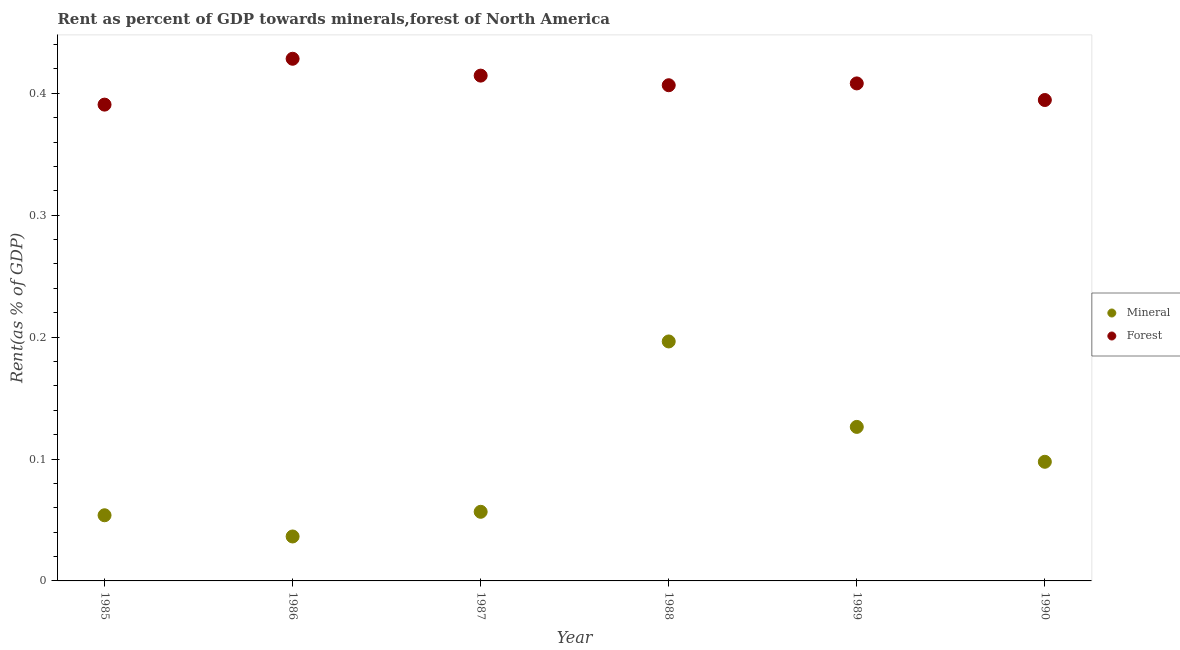How many different coloured dotlines are there?
Provide a succinct answer. 2. Is the number of dotlines equal to the number of legend labels?
Give a very brief answer. Yes. What is the mineral rent in 1985?
Offer a very short reply. 0.05. Across all years, what is the maximum forest rent?
Offer a terse response. 0.43. Across all years, what is the minimum forest rent?
Make the answer very short. 0.39. In which year was the mineral rent maximum?
Offer a very short reply. 1988. In which year was the mineral rent minimum?
Ensure brevity in your answer.  1986. What is the total forest rent in the graph?
Ensure brevity in your answer.  2.44. What is the difference between the mineral rent in 1988 and that in 1989?
Your answer should be very brief. 0.07. What is the difference between the mineral rent in 1990 and the forest rent in 1986?
Provide a short and direct response. -0.33. What is the average forest rent per year?
Give a very brief answer. 0.41. In the year 1990, what is the difference between the forest rent and mineral rent?
Keep it short and to the point. 0.3. What is the ratio of the forest rent in 1986 to that in 1990?
Give a very brief answer. 1.09. Is the mineral rent in 1986 less than that in 1989?
Your answer should be compact. Yes. What is the difference between the highest and the second highest mineral rent?
Your answer should be compact. 0.07. What is the difference between the highest and the lowest forest rent?
Offer a terse response. 0.04. Is the sum of the mineral rent in 1985 and 1987 greater than the maximum forest rent across all years?
Your answer should be compact. No. Is the mineral rent strictly greater than the forest rent over the years?
Your answer should be very brief. No. Is the forest rent strictly less than the mineral rent over the years?
Offer a terse response. No. What is the difference between two consecutive major ticks on the Y-axis?
Give a very brief answer. 0.1. Does the graph contain any zero values?
Ensure brevity in your answer.  No. Where does the legend appear in the graph?
Provide a succinct answer. Center right. How many legend labels are there?
Make the answer very short. 2. What is the title of the graph?
Offer a very short reply. Rent as percent of GDP towards minerals,forest of North America. Does "Urban agglomerations" appear as one of the legend labels in the graph?
Your answer should be compact. No. What is the label or title of the Y-axis?
Provide a succinct answer. Rent(as % of GDP). What is the Rent(as % of GDP) of Mineral in 1985?
Your answer should be compact. 0.05. What is the Rent(as % of GDP) of Forest in 1985?
Provide a succinct answer. 0.39. What is the Rent(as % of GDP) of Mineral in 1986?
Offer a very short reply. 0.04. What is the Rent(as % of GDP) in Forest in 1986?
Your answer should be very brief. 0.43. What is the Rent(as % of GDP) in Mineral in 1987?
Give a very brief answer. 0.06. What is the Rent(as % of GDP) of Forest in 1987?
Ensure brevity in your answer.  0.41. What is the Rent(as % of GDP) of Mineral in 1988?
Your answer should be compact. 0.2. What is the Rent(as % of GDP) in Forest in 1988?
Ensure brevity in your answer.  0.41. What is the Rent(as % of GDP) of Mineral in 1989?
Ensure brevity in your answer.  0.13. What is the Rent(as % of GDP) in Forest in 1989?
Give a very brief answer. 0.41. What is the Rent(as % of GDP) of Mineral in 1990?
Make the answer very short. 0.1. What is the Rent(as % of GDP) in Forest in 1990?
Provide a succinct answer. 0.39. Across all years, what is the maximum Rent(as % of GDP) of Mineral?
Keep it short and to the point. 0.2. Across all years, what is the maximum Rent(as % of GDP) in Forest?
Ensure brevity in your answer.  0.43. Across all years, what is the minimum Rent(as % of GDP) in Mineral?
Provide a short and direct response. 0.04. Across all years, what is the minimum Rent(as % of GDP) of Forest?
Offer a very short reply. 0.39. What is the total Rent(as % of GDP) in Mineral in the graph?
Make the answer very short. 0.57. What is the total Rent(as % of GDP) in Forest in the graph?
Provide a short and direct response. 2.44. What is the difference between the Rent(as % of GDP) in Mineral in 1985 and that in 1986?
Make the answer very short. 0.02. What is the difference between the Rent(as % of GDP) of Forest in 1985 and that in 1986?
Your answer should be compact. -0.04. What is the difference between the Rent(as % of GDP) of Mineral in 1985 and that in 1987?
Offer a very short reply. -0. What is the difference between the Rent(as % of GDP) in Forest in 1985 and that in 1987?
Provide a short and direct response. -0.02. What is the difference between the Rent(as % of GDP) of Mineral in 1985 and that in 1988?
Your answer should be very brief. -0.14. What is the difference between the Rent(as % of GDP) in Forest in 1985 and that in 1988?
Provide a succinct answer. -0.02. What is the difference between the Rent(as % of GDP) in Mineral in 1985 and that in 1989?
Your response must be concise. -0.07. What is the difference between the Rent(as % of GDP) in Forest in 1985 and that in 1989?
Your response must be concise. -0.02. What is the difference between the Rent(as % of GDP) in Mineral in 1985 and that in 1990?
Ensure brevity in your answer.  -0.04. What is the difference between the Rent(as % of GDP) of Forest in 1985 and that in 1990?
Your answer should be compact. -0. What is the difference between the Rent(as % of GDP) of Mineral in 1986 and that in 1987?
Your response must be concise. -0.02. What is the difference between the Rent(as % of GDP) of Forest in 1986 and that in 1987?
Make the answer very short. 0.01. What is the difference between the Rent(as % of GDP) in Mineral in 1986 and that in 1988?
Offer a very short reply. -0.16. What is the difference between the Rent(as % of GDP) in Forest in 1986 and that in 1988?
Your response must be concise. 0.02. What is the difference between the Rent(as % of GDP) of Mineral in 1986 and that in 1989?
Your response must be concise. -0.09. What is the difference between the Rent(as % of GDP) in Forest in 1986 and that in 1989?
Your response must be concise. 0.02. What is the difference between the Rent(as % of GDP) of Mineral in 1986 and that in 1990?
Provide a short and direct response. -0.06. What is the difference between the Rent(as % of GDP) of Forest in 1986 and that in 1990?
Offer a terse response. 0.03. What is the difference between the Rent(as % of GDP) in Mineral in 1987 and that in 1988?
Your answer should be very brief. -0.14. What is the difference between the Rent(as % of GDP) of Forest in 1987 and that in 1988?
Offer a terse response. 0.01. What is the difference between the Rent(as % of GDP) of Mineral in 1987 and that in 1989?
Provide a short and direct response. -0.07. What is the difference between the Rent(as % of GDP) in Forest in 1987 and that in 1989?
Your response must be concise. 0.01. What is the difference between the Rent(as % of GDP) in Mineral in 1987 and that in 1990?
Your response must be concise. -0.04. What is the difference between the Rent(as % of GDP) in Mineral in 1988 and that in 1989?
Provide a succinct answer. 0.07. What is the difference between the Rent(as % of GDP) in Forest in 1988 and that in 1989?
Keep it short and to the point. -0. What is the difference between the Rent(as % of GDP) of Mineral in 1988 and that in 1990?
Your answer should be compact. 0.1. What is the difference between the Rent(as % of GDP) of Forest in 1988 and that in 1990?
Your answer should be compact. 0.01. What is the difference between the Rent(as % of GDP) of Mineral in 1989 and that in 1990?
Your answer should be very brief. 0.03. What is the difference between the Rent(as % of GDP) of Forest in 1989 and that in 1990?
Offer a very short reply. 0.01. What is the difference between the Rent(as % of GDP) of Mineral in 1985 and the Rent(as % of GDP) of Forest in 1986?
Your answer should be very brief. -0.37. What is the difference between the Rent(as % of GDP) in Mineral in 1985 and the Rent(as % of GDP) in Forest in 1987?
Your answer should be compact. -0.36. What is the difference between the Rent(as % of GDP) in Mineral in 1985 and the Rent(as % of GDP) in Forest in 1988?
Offer a terse response. -0.35. What is the difference between the Rent(as % of GDP) of Mineral in 1985 and the Rent(as % of GDP) of Forest in 1989?
Provide a succinct answer. -0.35. What is the difference between the Rent(as % of GDP) of Mineral in 1985 and the Rent(as % of GDP) of Forest in 1990?
Your response must be concise. -0.34. What is the difference between the Rent(as % of GDP) in Mineral in 1986 and the Rent(as % of GDP) in Forest in 1987?
Offer a very short reply. -0.38. What is the difference between the Rent(as % of GDP) of Mineral in 1986 and the Rent(as % of GDP) of Forest in 1988?
Offer a terse response. -0.37. What is the difference between the Rent(as % of GDP) of Mineral in 1986 and the Rent(as % of GDP) of Forest in 1989?
Make the answer very short. -0.37. What is the difference between the Rent(as % of GDP) in Mineral in 1986 and the Rent(as % of GDP) in Forest in 1990?
Your answer should be compact. -0.36. What is the difference between the Rent(as % of GDP) in Mineral in 1987 and the Rent(as % of GDP) in Forest in 1988?
Offer a very short reply. -0.35. What is the difference between the Rent(as % of GDP) in Mineral in 1987 and the Rent(as % of GDP) in Forest in 1989?
Your answer should be compact. -0.35. What is the difference between the Rent(as % of GDP) of Mineral in 1987 and the Rent(as % of GDP) of Forest in 1990?
Keep it short and to the point. -0.34. What is the difference between the Rent(as % of GDP) in Mineral in 1988 and the Rent(as % of GDP) in Forest in 1989?
Provide a short and direct response. -0.21. What is the difference between the Rent(as % of GDP) of Mineral in 1988 and the Rent(as % of GDP) of Forest in 1990?
Your answer should be compact. -0.2. What is the difference between the Rent(as % of GDP) of Mineral in 1989 and the Rent(as % of GDP) of Forest in 1990?
Offer a very short reply. -0.27. What is the average Rent(as % of GDP) in Mineral per year?
Provide a short and direct response. 0.09. What is the average Rent(as % of GDP) of Forest per year?
Provide a short and direct response. 0.41. In the year 1985, what is the difference between the Rent(as % of GDP) of Mineral and Rent(as % of GDP) of Forest?
Your response must be concise. -0.34. In the year 1986, what is the difference between the Rent(as % of GDP) of Mineral and Rent(as % of GDP) of Forest?
Your response must be concise. -0.39. In the year 1987, what is the difference between the Rent(as % of GDP) in Mineral and Rent(as % of GDP) in Forest?
Offer a terse response. -0.36. In the year 1988, what is the difference between the Rent(as % of GDP) in Mineral and Rent(as % of GDP) in Forest?
Your answer should be compact. -0.21. In the year 1989, what is the difference between the Rent(as % of GDP) in Mineral and Rent(as % of GDP) in Forest?
Make the answer very short. -0.28. In the year 1990, what is the difference between the Rent(as % of GDP) of Mineral and Rent(as % of GDP) of Forest?
Your answer should be compact. -0.3. What is the ratio of the Rent(as % of GDP) of Mineral in 1985 to that in 1986?
Offer a very short reply. 1.48. What is the ratio of the Rent(as % of GDP) of Forest in 1985 to that in 1986?
Your answer should be compact. 0.91. What is the ratio of the Rent(as % of GDP) in Mineral in 1985 to that in 1987?
Your answer should be compact. 0.95. What is the ratio of the Rent(as % of GDP) in Forest in 1985 to that in 1987?
Offer a terse response. 0.94. What is the ratio of the Rent(as % of GDP) in Mineral in 1985 to that in 1988?
Your answer should be compact. 0.27. What is the ratio of the Rent(as % of GDP) of Forest in 1985 to that in 1988?
Your answer should be compact. 0.96. What is the ratio of the Rent(as % of GDP) of Mineral in 1985 to that in 1989?
Ensure brevity in your answer.  0.43. What is the ratio of the Rent(as % of GDP) in Forest in 1985 to that in 1989?
Keep it short and to the point. 0.96. What is the ratio of the Rent(as % of GDP) of Mineral in 1985 to that in 1990?
Make the answer very short. 0.55. What is the ratio of the Rent(as % of GDP) of Mineral in 1986 to that in 1987?
Your answer should be very brief. 0.64. What is the ratio of the Rent(as % of GDP) of Forest in 1986 to that in 1987?
Provide a short and direct response. 1.03. What is the ratio of the Rent(as % of GDP) in Mineral in 1986 to that in 1988?
Provide a succinct answer. 0.19. What is the ratio of the Rent(as % of GDP) of Forest in 1986 to that in 1988?
Give a very brief answer. 1.05. What is the ratio of the Rent(as % of GDP) in Mineral in 1986 to that in 1989?
Provide a succinct answer. 0.29. What is the ratio of the Rent(as % of GDP) in Forest in 1986 to that in 1989?
Make the answer very short. 1.05. What is the ratio of the Rent(as % of GDP) of Mineral in 1986 to that in 1990?
Keep it short and to the point. 0.37. What is the ratio of the Rent(as % of GDP) in Forest in 1986 to that in 1990?
Give a very brief answer. 1.09. What is the ratio of the Rent(as % of GDP) of Mineral in 1987 to that in 1988?
Keep it short and to the point. 0.29. What is the ratio of the Rent(as % of GDP) of Forest in 1987 to that in 1988?
Your response must be concise. 1.02. What is the ratio of the Rent(as % of GDP) in Mineral in 1987 to that in 1989?
Offer a terse response. 0.45. What is the ratio of the Rent(as % of GDP) in Forest in 1987 to that in 1989?
Make the answer very short. 1.02. What is the ratio of the Rent(as % of GDP) in Mineral in 1987 to that in 1990?
Keep it short and to the point. 0.58. What is the ratio of the Rent(as % of GDP) of Forest in 1987 to that in 1990?
Make the answer very short. 1.05. What is the ratio of the Rent(as % of GDP) of Mineral in 1988 to that in 1989?
Your answer should be compact. 1.55. What is the ratio of the Rent(as % of GDP) of Mineral in 1988 to that in 1990?
Your response must be concise. 2.01. What is the ratio of the Rent(as % of GDP) in Forest in 1988 to that in 1990?
Your response must be concise. 1.03. What is the ratio of the Rent(as % of GDP) of Mineral in 1989 to that in 1990?
Your answer should be compact. 1.29. What is the ratio of the Rent(as % of GDP) of Forest in 1989 to that in 1990?
Make the answer very short. 1.03. What is the difference between the highest and the second highest Rent(as % of GDP) in Mineral?
Make the answer very short. 0.07. What is the difference between the highest and the second highest Rent(as % of GDP) of Forest?
Ensure brevity in your answer.  0.01. What is the difference between the highest and the lowest Rent(as % of GDP) of Mineral?
Offer a terse response. 0.16. What is the difference between the highest and the lowest Rent(as % of GDP) in Forest?
Your answer should be very brief. 0.04. 